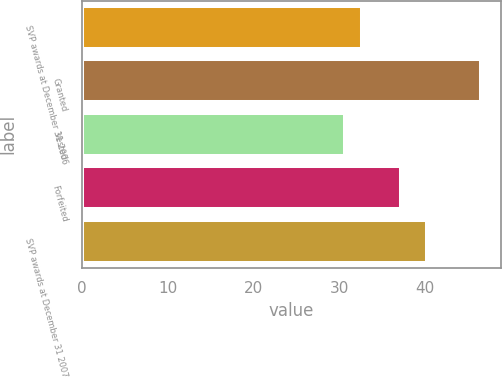Convert chart to OTSL. <chart><loc_0><loc_0><loc_500><loc_500><bar_chart><fcel>SVP awards at December 31 2006<fcel>Granted<fcel>Vested<fcel>Forfeited<fcel>SVP awards at December 31 2007<nl><fcel>32.63<fcel>46.49<fcel>30.64<fcel>37.19<fcel>40.2<nl></chart> 